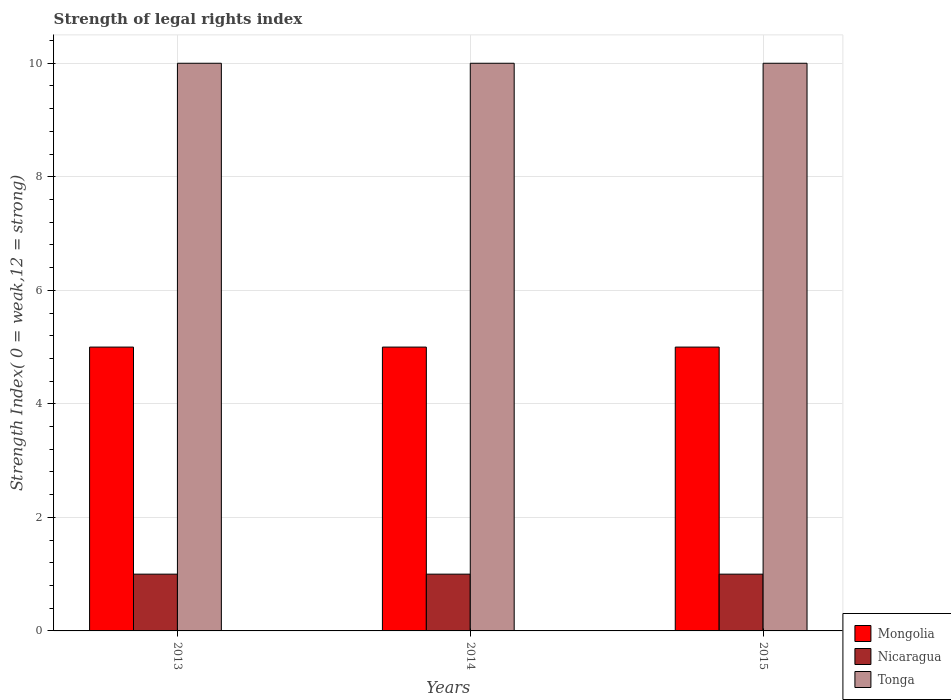Are the number of bars on each tick of the X-axis equal?
Your answer should be compact. Yes. How many bars are there on the 1st tick from the left?
Your answer should be compact. 3. How many bars are there on the 1st tick from the right?
Give a very brief answer. 3. What is the label of the 1st group of bars from the left?
Give a very brief answer. 2013. What is the strength index in Nicaragua in 2015?
Give a very brief answer. 1. Across all years, what is the maximum strength index in Nicaragua?
Your response must be concise. 1. Across all years, what is the minimum strength index in Mongolia?
Your answer should be very brief. 5. What is the total strength index in Tonga in the graph?
Provide a succinct answer. 30. What is the difference between the strength index in Nicaragua in 2015 and the strength index in Tonga in 2013?
Keep it short and to the point. -9. In the year 2015, what is the difference between the strength index in Nicaragua and strength index in Tonga?
Keep it short and to the point. -9. What is the ratio of the strength index in Mongolia in 2013 to that in 2015?
Offer a terse response. 1. Is the strength index in Tonga in 2013 less than that in 2014?
Make the answer very short. No. Is the difference between the strength index in Nicaragua in 2013 and 2015 greater than the difference between the strength index in Tonga in 2013 and 2015?
Your answer should be very brief. No. What is the difference between the highest and the second highest strength index in Mongolia?
Provide a short and direct response. 0. What is the difference between the highest and the lowest strength index in Nicaragua?
Ensure brevity in your answer.  0. What does the 1st bar from the left in 2015 represents?
Offer a very short reply. Mongolia. What does the 2nd bar from the right in 2015 represents?
Provide a succinct answer. Nicaragua. How many bars are there?
Provide a succinct answer. 9. How many years are there in the graph?
Ensure brevity in your answer.  3. What is the difference between two consecutive major ticks on the Y-axis?
Your answer should be very brief. 2. How many legend labels are there?
Your answer should be very brief. 3. How are the legend labels stacked?
Provide a succinct answer. Vertical. What is the title of the graph?
Your answer should be compact. Strength of legal rights index. Does "Turkey" appear as one of the legend labels in the graph?
Make the answer very short. No. What is the label or title of the Y-axis?
Keep it short and to the point. Strength Index( 0 = weak,12 = strong). What is the Strength Index( 0 = weak,12 = strong) in Tonga in 2013?
Your answer should be compact. 10. What is the Strength Index( 0 = weak,12 = strong) of Mongolia in 2014?
Provide a short and direct response. 5. What is the Strength Index( 0 = weak,12 = strong) of Nicaragua in 2014?
Your answer should be very brief. 1. What is the Strength Index( 0 = weak,12 = strong) of Mongolia in 2015?
Offer a terse response. 5. What is the Strength Index( 0 = weak,12 = strong) in Nicaragua in 2015?
Provide a succinct answer. 1. Across all years, what is the maximum Strength Index( 0 = weak,12 = strong) in Mongolia?
Offer a very short reply. 5. What is the total Strength Index( 0 = weak,12 = strong) in Nicaragua in the graph?
Keep it short and to the point. 3. What is the total Strength Index( 0 = weak,12 = strong) of Tonga in the graph?
Offer a terse response. 30. What is the difference between the Strength Index( 0 = weak,12 = strong) in Mongolia in 2013 and that in 2014?
Keep it short and to the point. 0. What is the difference between the Strength Index( 0 = weak,12 = strong) of Tonga in 2013 and that in 2014?
Your answer should be compact. 0. What is the difference between the Strength Index( 0 = weak,12 = strong) in Tonga in 2013 and that in 2015?
Your response must be concise. 0. What is the difference between the Strength Index( 0 = weak,12 = strong) in Mongolia in 2014 and that in 2015?
Provide a short and direct response. 0. What is the difference between the Strength Index( 0 = weak,12 = strong) in Nicaragua in 2014 and that in 2015?
Give a very brief answer. 0. What is the difference between the Strength Index( 0 = weak,12 = strong) of Mongolia in 2013 and the Strength Index( 0 = weak,12 = strong) of Tonga in 2014?
Ensure brevity in your answer.  -5. What is the difference between the Strength Index( 0 = weak,12 = strong) of Nicaragua in 2013 and the Strength Index( 0 = weak,12 = strong) of Tonga in 2014?
Make the answer very short. -9. What is the average Strength Index( 0 = weak,12 = strong) of Tonga per year?
Keep it short and to the point. 10. In the year 2014, what is the difference between the Strength Index( 0 = weak,12 = strong) in Mongolia and Strength Index( 0 = weak,12 = strong) in Nicaragua?
Your response must be concise. 4. In the year 2014, what is the difference between the Strength Index( 0 = weak,12 = strong) in Mongolia and Strength Index( 0 = weak,12 = strong) in Tonga?
Offer a terse response. -5. In the year 2014, what is the difference between the Strength Index( 0 = weak,12 = strong) in Nicaragua and Strength Index( 0 = weak,12 = strong) in Tonga?
Give a very brief answer. -9. In the year 2015, what is the difference between the Strength Index( 0 = weak,12 = strong) in Mongolia and Strength Index( 0 = weak,12 = strong) in Nicaragua?
Provide a short and direct response. 4. What is the ratio of the Strength Index( 0 = weak,12 = strong) of Mongolia in 2013 to that in 2014?
Give a very brief answer. 1. What is the ratio of the Strength Index( 0 = weak,12 = strong) of Nicaragua in 2013 to that in 2014?
Offer a terse response. 1. What is the ratio of the Strength Index( 0 = weak,12 = strong) of Tonga in 2013 to that in 2014?
Make the answer very short. 1. What is the ratio of the Strength Index( 0 = weak,12 = strong) of Nicaragua in 2013 to that in 2015?
Offer a very short reply. 1. What is the ratio of the Strength Index( 0 = weak,12 = strong) of Tonga in 2013 to that in 2015?
Provide a short and direct response. 1. What is the ratio of the Strength Index( 0 = weak,12 = strong) in Nicaragua in 2014 to that in 2015?
Make the answer very short. 1. What is the ratio of the Strength Index( 0 = weak,12 = strong) of Tonga in 2014 to that in 2015?
Make the answer very short. 1. What is the difference between the highest and the second highest Strength Index( 0 = weak,12 = strong) in Nicaragua?
Provide a succinct answer. 0. What is the difference between the highest and the second highest Strength Index( 0 = weak,12 = strong) in Tonga?
Provide a succinct answer. 0. What is the difference between the highest and the lowest Strength Index( 0 = weak,12 = strong) of Mongolia?
Give a very brief answer. 0. What is the difference between the highest and the lowest Strength Index( 0 = weak,12 = strong) in Tonga?
Your answer should be very brief. 0. 